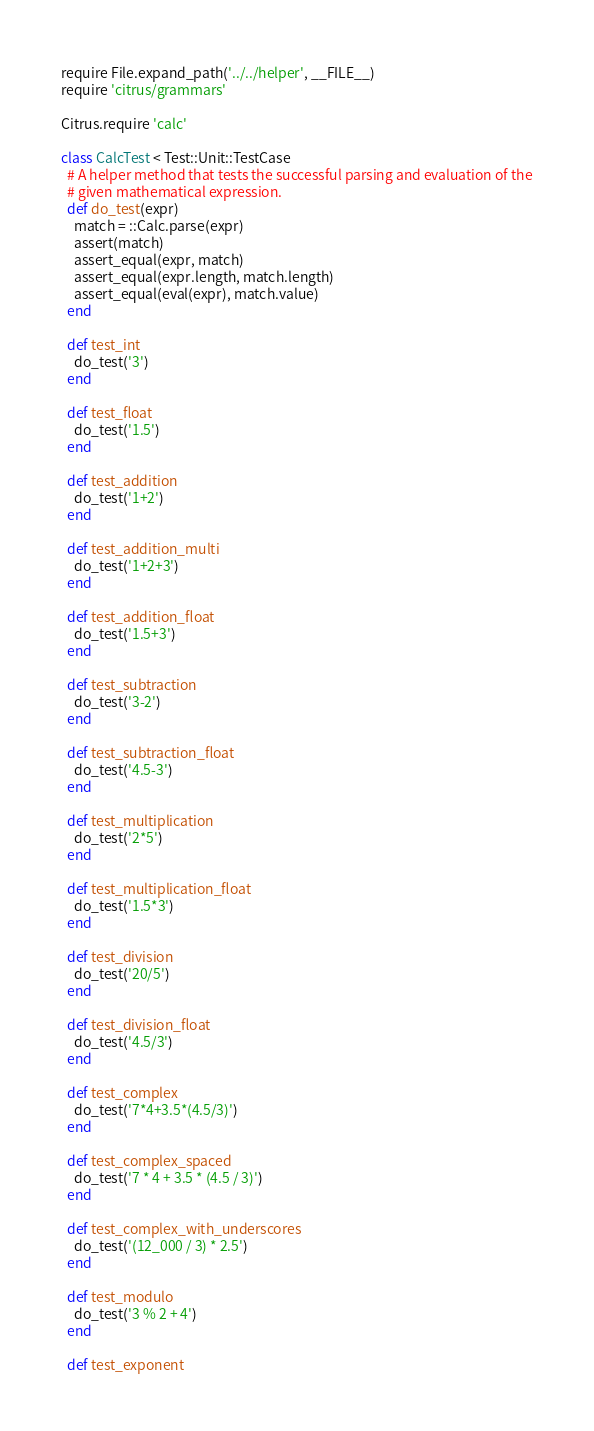Convert code to text. <code><loc_0><loc_0><loc_500><loc_500><_Ruby_>require File.expand_path('../../helper', __FILE__)
require 'citrus/grammars'

Citrus.require 'calc'

class CalcTest < Test::Unit::TestCase
  # A helper method that tests the successful parsing and evaluation of the
  # given mathematical expression.
  def do_test(expr)
    match = ::Calc.parse(expr)
    assert(match)
    assert_equal(expr, match)
    assert_equal(expr.length, match.length)
    assert_equal(eval(expr), match.value)
  end

  def test_int
    do_test('3')
  end

  def test_float
    do_test('1.5')
  end

  def test_addition
    do_test('1+2')
  end

  def test_addition_multi
    do_test('1+2+3')
  end

  def test_addition_float
    do_test('1.5+3')
  end

  def test_subtraction
    do_test('3-2')
  end

  def test_subtraction_float
    do_test('4.5-3')
  end

  def test_multiplication
    do_test('2*5')
  end

  def test_multiplication_float
    do_test('1.5*3')
  end

  def test_division
    do_test('20/5')
  end

  def test_division_float
    do_test('4.5/3')
  end

  def test_complex
    do_test('7*4+3.5*(4.5/3)')
  end

  def test_complex_spaced
    do_test('7 * 4 + 3.5 * (4.5 / 3)')
  end

  def test_complex_with_underscores
    do_test('(12_000 / 3) * 2.5')
  end

  def test_modulo
    do_test('3 % 2 + 4')
  end

  def test_exponent</code> 